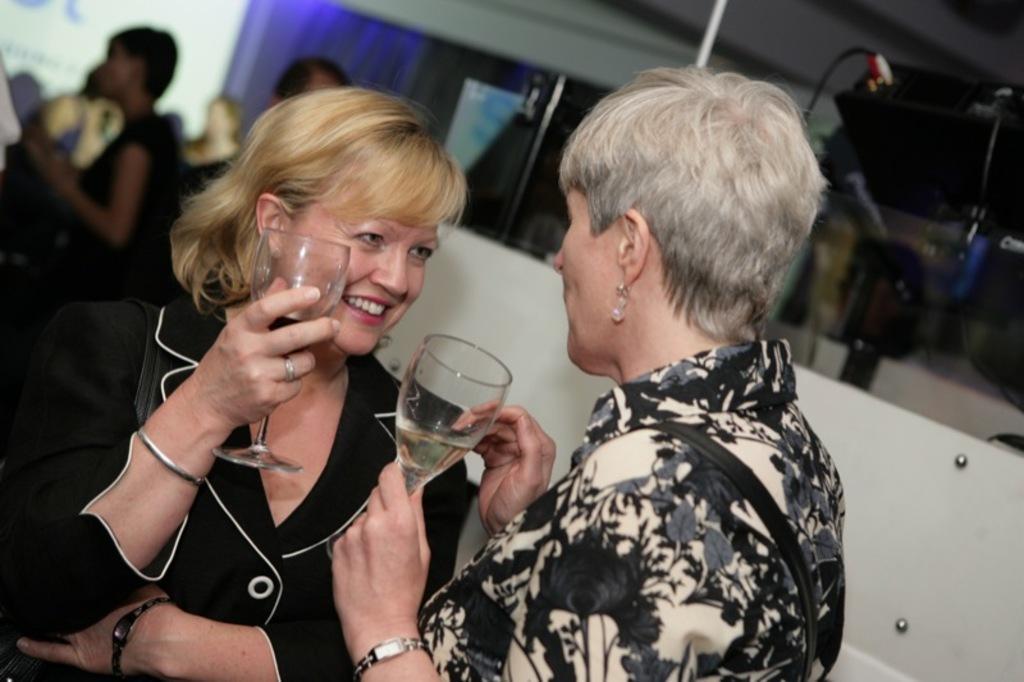Please provide a concise description of this image. In this image I can see a woman wearing black dress and a woman wearing black and cream dress are holding wine glasses in their hands. In the background I can see few other person's, a screen , some curtains and the white colored surface. 